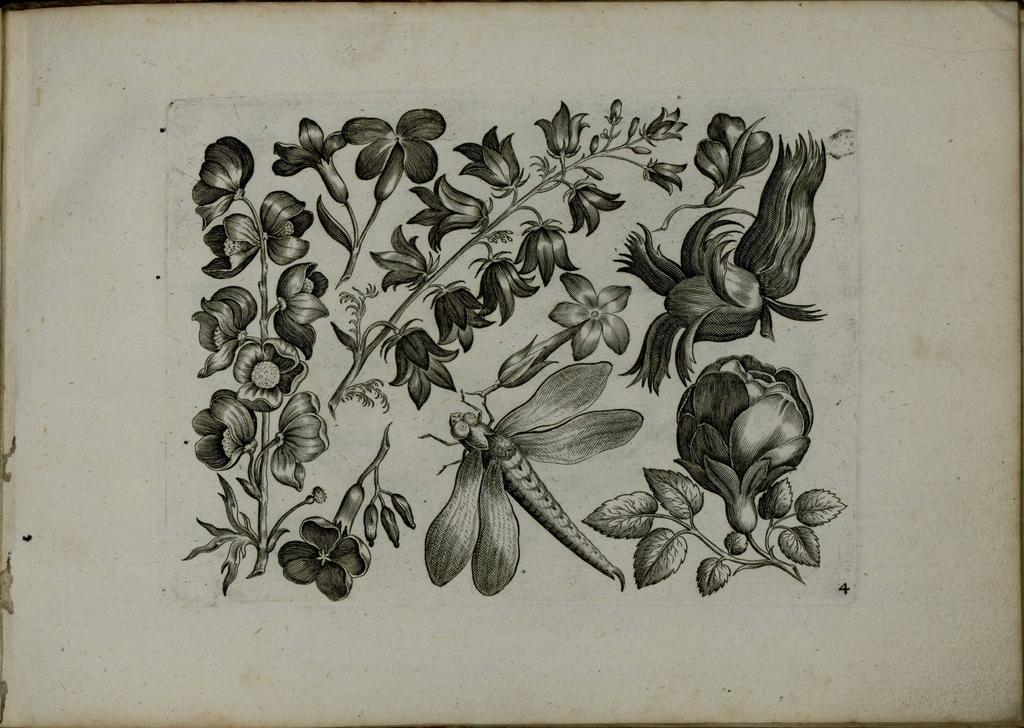What is depicted in the drawing in the image? The image contains a drawing of a plant. What features can be observed on the plant in the drawing? The plant in the drawing has branches and flowers. Are there any other living organisms present in the drawing? Yes, there is an insect in the drawing. What is the medium on which the drawing is made? The drawing is on a piece of paper. What type of fang can be seen on the turkey in the drawing? There is no turkey or fang present in the drawing; it features a plant with branches, flowers, and an insect. 